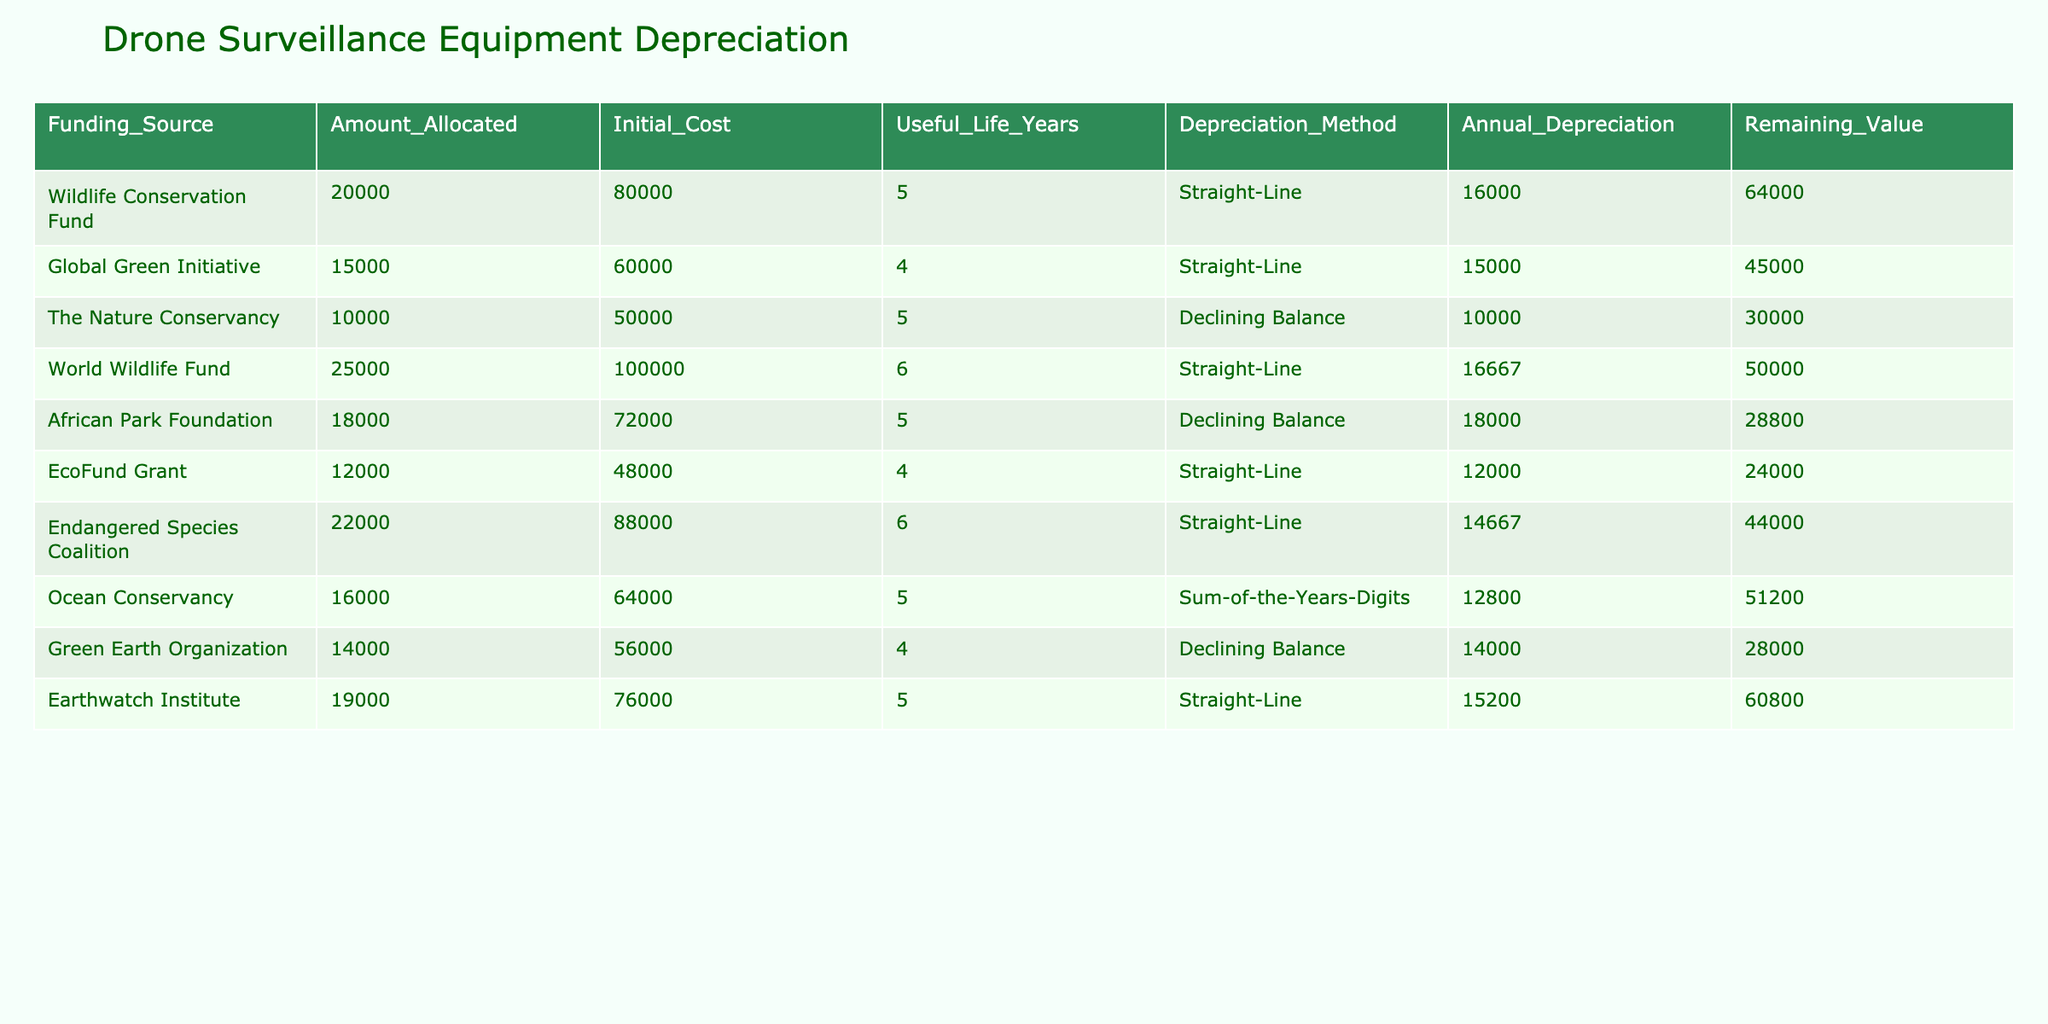What is the total amount allocated for drone surveillance equipment? To find the total amount allocated, sum the "Amount_Allocated" column values: 20000 + 15000 + 10000 + 25000 + 18000 + 12000 + 22000 + 16000 + 14000 + 19000 = 157000.
Answer: 157000 Which funding source has the highest annual depreciation? By scanning the "Annual_Depreciation" column, we find that the "Wildlife Conservation Fund" has an annual depreciation of 16000, which is the highest value listed.
Answer: Wildlife Conservation Fund Is the remaining value for the "EcoFund Grant" greater than 20000? The "Remaining_Value" for the "EcoFund Grant" is 24000, which is indeed greater than 20000.
Answer: Yes What is the average remaining value of all funding sources? To calculate the average remaining value, first sum the "Remaining_Value" column: 64000 + 45000 + 30000 + 50000 + 28800 + 24000 + 44000 + 51200 + 28000 + 60800 = 339800. There are 10 funding sources, so the average is 339800 / 10 = 33980.
Answer: 33980 Which funding source has the lowest initial cost, and what is that cost? The "The Nature Conservancy" has the lowest "Initial_Cost" of 50000.
Answer: The Nature Conservancy, 50000 If we combine the amounts allocated from "African Park Foundation" and "EcoFund Grant," what is the total? Add the values: 18000 (African Park Foundation) + 12000 (EcoFund Grant) = 30000.
Answer: 30000 Which funding sources have a useful life of more than 5 years? Review the "Useful_Life_Years" column: "World Wildlife Fund" (6 years) and "Endangered Species Coalition" (6 years) are the only sources with a useful life greater than 5 years.
Answer: World Wildlife Fund, Endangered Species Coalition What is the difference between the highest and lowest remaining value? The highest remaining value is 64000 (Wildlife Conservation Fund) and the lowest is 24000 (EcoFund Grant). The difference is 64000 - 24000 = 40000.
Answer: 40000 